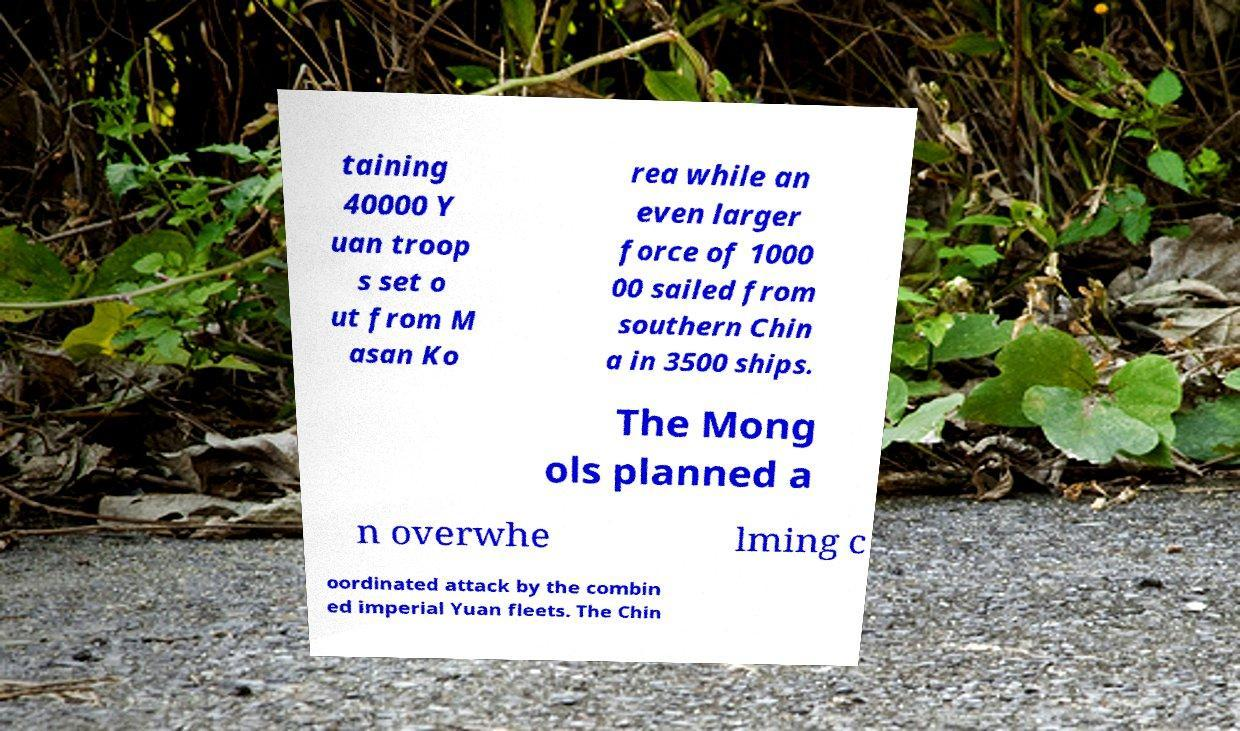Could you extract and type out the text from this image? taining 40000 Y uan troop s set o ut from M asan Ko rea while an even larger force of 1000 00 sailed from southern Chin a in 3500 ships. The Mong ols planned a n overwhe lming c oordinated attack by the combin ed imperial Yuan fleets. The Chin 